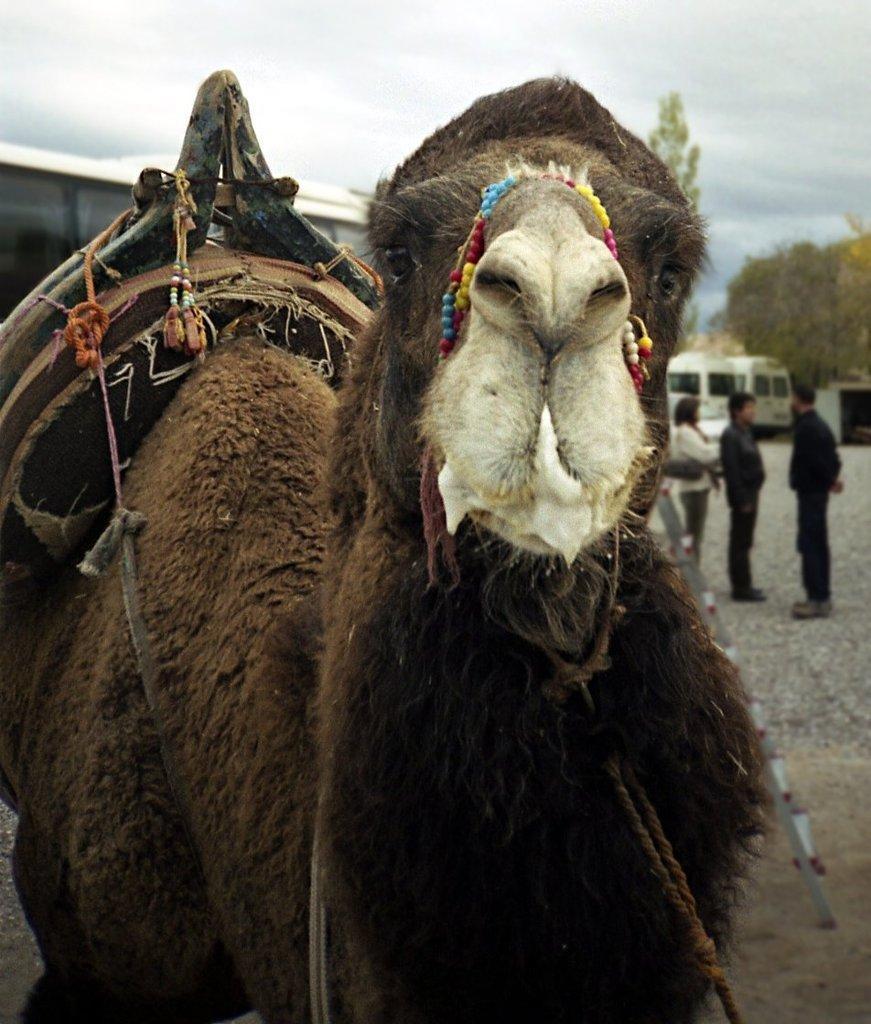In one or two sentences, can you explain what this image depicts? We can see a camel and there are people standing. In the background we can see vehicles, trees and sky with clouds. 